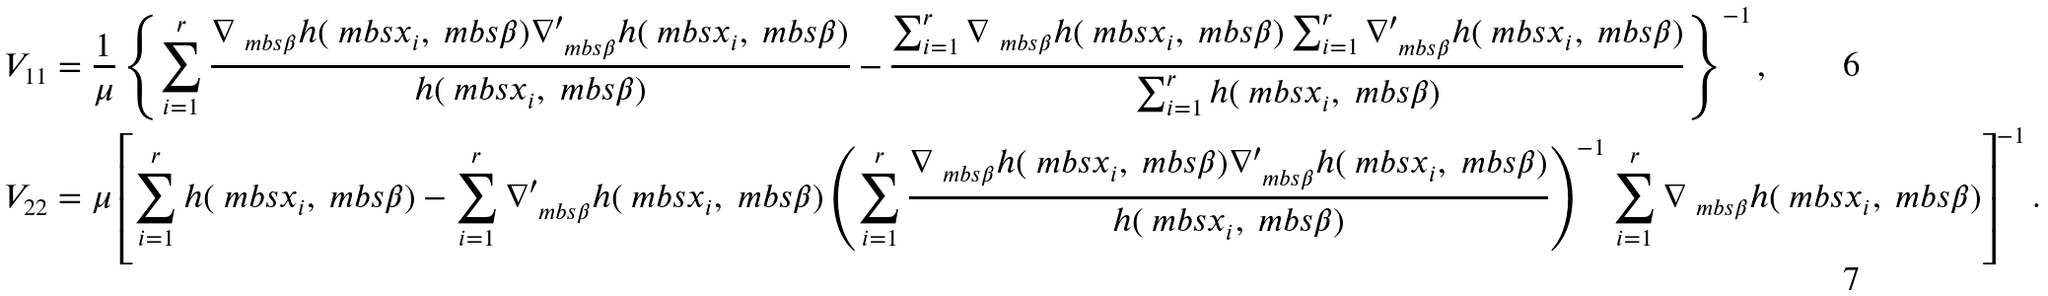<formula> <loc_0><loc_0><loc_500><loc_500>V _ { 1 1 } & = \frac { 1 } { \mu } \left \{ \sum _ { i = 1 } ^ { r } \frac { \nabla _ { \ m b s { \beta } } h ( \ m b s { x } _ { i } , \ m b s { \beta } ) \nabla _ { \ m b s { \beta } } ^ { \prime } h ( \ m b s { x } _ { i } , \ m b s { \beta } ) } { h ( \ m b s { x } _ { i } , \ m b s { \beta } ) } - \frac { \sum _ { i = 1 } ^ { r } \nabla _ { \ m b s { \beta } } h ( \ m b s { x } _ { i } , \ m b s { \beta } ) \sum _ { i = 1 } ^ { r } \nabla _ { \ m b s { \beta } } ^ { \prime } h ( \ m b s { x } _ { i } , \ m b s { \beta } ) } { \sum _ { i = 1 } ^ { r } h ( \ m b s { x } _ { i } , \ m b s { \beta } ) } \right \} ^ { - 1 } , \\ V _ { 2 2 } & = \mu \left [ \sum _ { i = 1 } ^ { r } h ( \ m b s { x } _ { i } , \ m b s { \beta } ) - \sum _ { i = 1 } ^ { r } \nabla _ { \ m b s { \beta } } ^ { \prime } h ( \ m b s { x } _ { i } , \ m b s { \beta } ) \left ( \sum _ { i = 1 } ^ { r } \frac { \nabla _ { \ m b s { \beta } } h ( \ m b s { x } _ { i } , \ m b s { \beta } ) \nabla _ { \ m b s { \beta } } ^ { \prime } h ( \ m b s { x } _ { i } , \ m b s { \beta } ) } { h ( \ m b s { x } _ { i } , \ m b s { \beta } ) } \right ) ^ { - 1 } \sum _ { i = 1 } ^ { r } \nabla _ { \ m b s { \beta } } h ( \ m b s { x } _ { i } , \ m b s { \beta } ) \right ] ^ { - 1 } .</formula> 